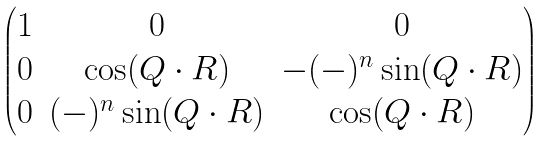<formula> <loc_0><loc_0><loc_500><loc_500>\begin{pmatrix} 1 & 0 & 0 \\ 0 & \cos ( { Q } \cdot { R } ) & - ( - ) ^ { n } \sin ( { Q } \cdot { R } ) \\ 0 & ( - ) ^ { n } \sin ( { Q } \cdot { R } ) & \cos ( { Q } \cdot { R } ) \end{pmatrix}</formula> 